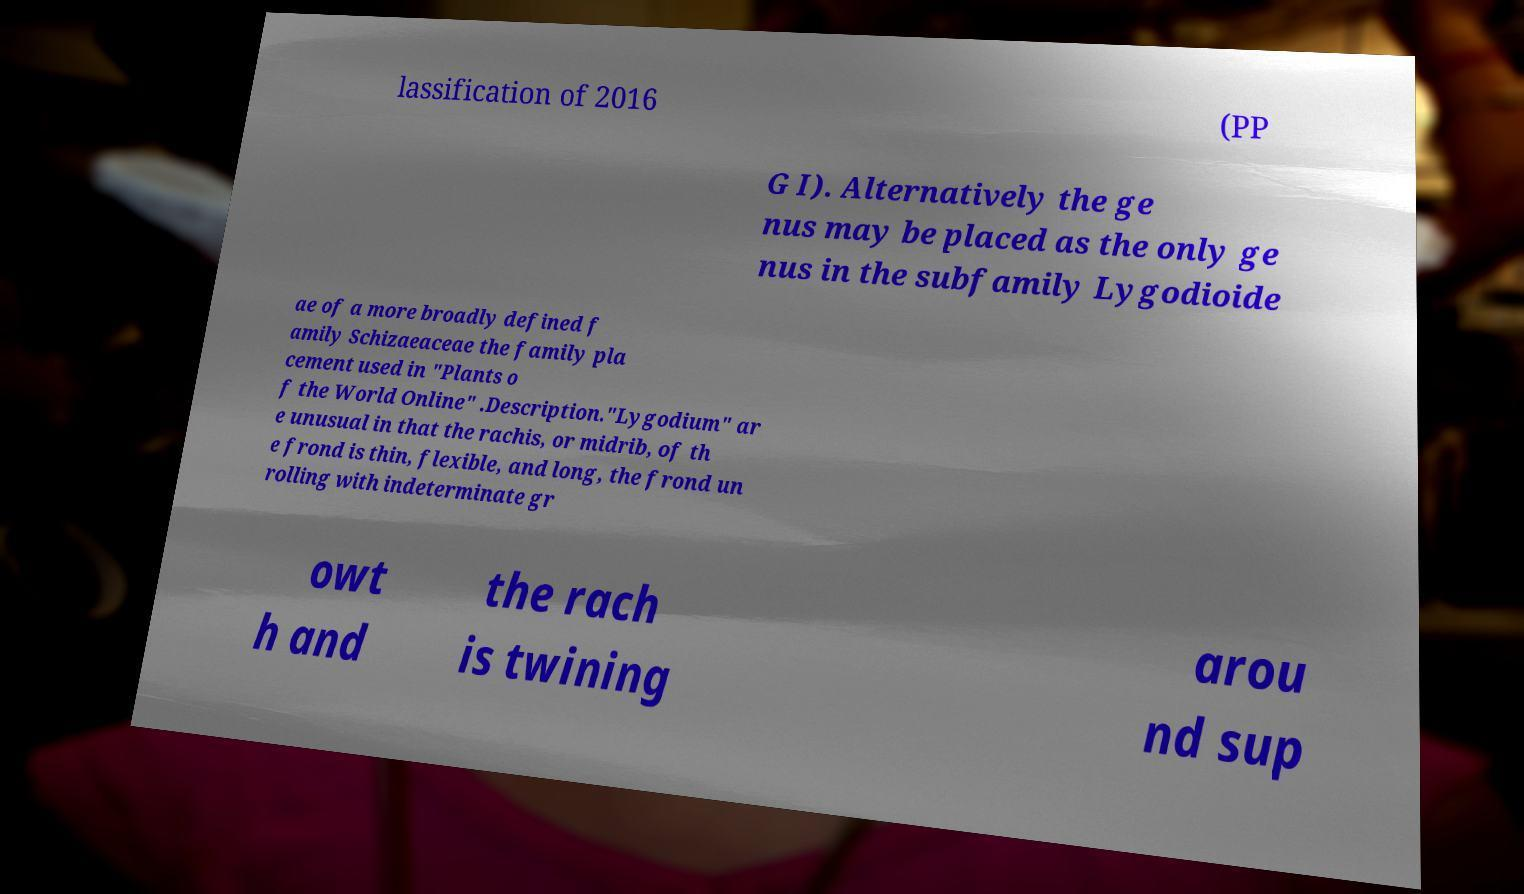Can you read and provide the text displayed in the image?This photo seems to have some interesting text. Can you extract and type it out for me? lassification of 2016 (PP G I). Alternatively the ge nus may be placed as the only ge nus in the subfamily Lygodioide ae of a more broadly defined f amily Schizaeaceae the family pla cement used in "Plants o f the World Online" .Description."Lygodium" ar e unusual in that the rachis, or midrib, of th e frond is thin, flexible, and long, the frond un rolling with indeterminate gr owt h and the rach is twining arou nd sup 